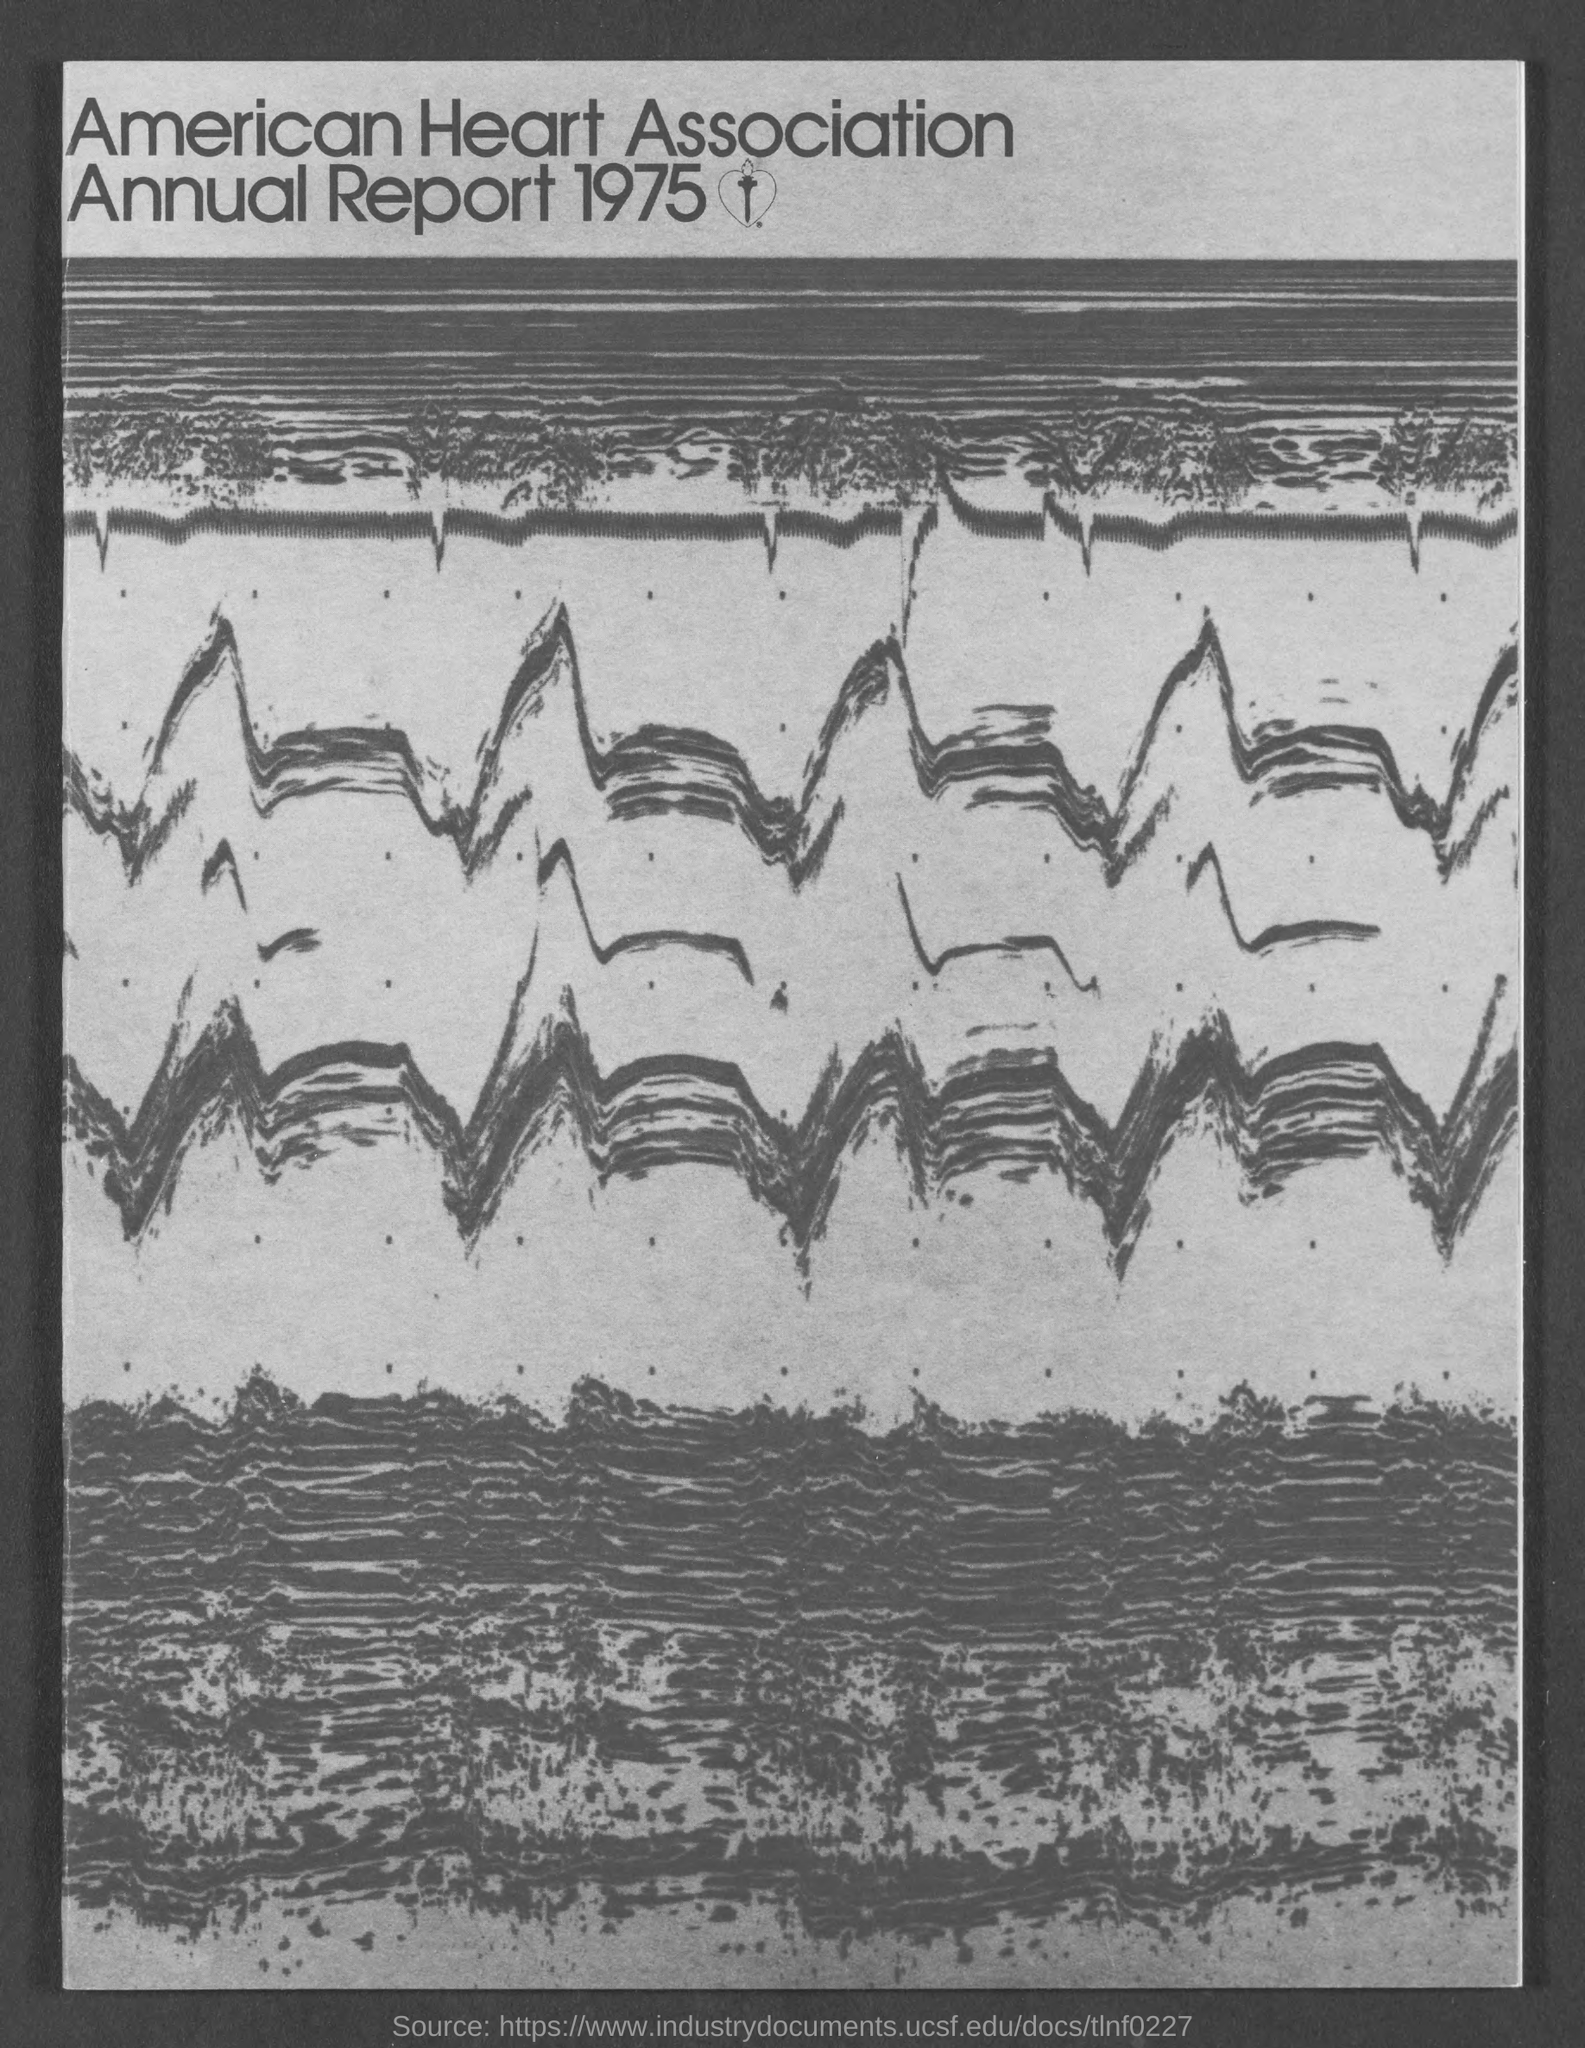Which annual report is mentioned here?
Your answer should be very brief. AMERICAN HEART ASSOCIATION. 